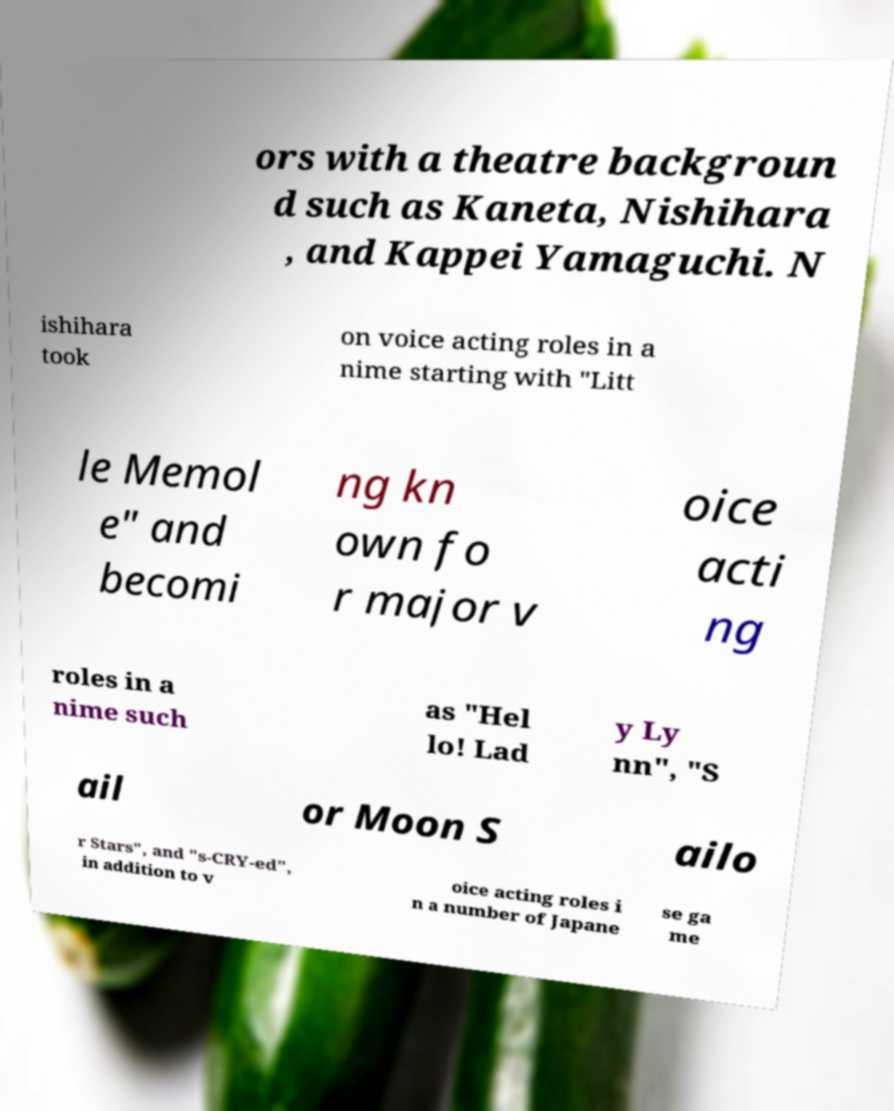Please identify and transcribe the text found in this image. ors with a theatre backgroun d such as Kaneta, Nishihara , and Kappei Yamaguchi. N ishihara took on voice acting roles in a nime starting with "Litt le Memol e" and becomi ng kn own fo r major v oice acti ng roles in a nime such as "Hel lo! Lad y Ly nn", "S ail or Moon S ailo r Stars", and "s-CRY-ed", in addition to v oice acting roles i n a number of Japane se ga me 